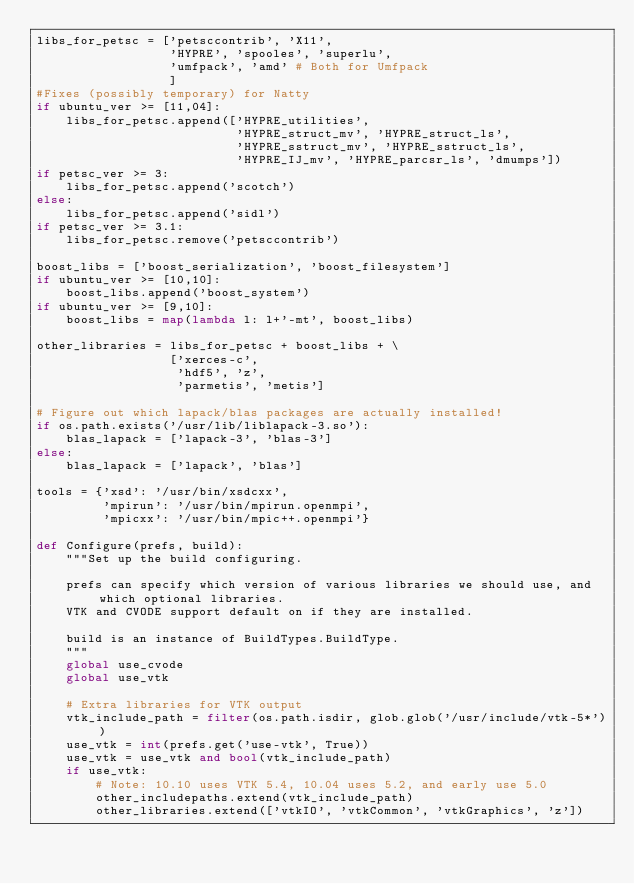Convert code to text. <code><loc_0><loc_0><loc_500><loc_500><_Python_>libs_for_petsc = ['petsccontrib', 'X11',
                  'HYPRE', 'spooles', 'superlu',
                  'umfpack', 'amd' # Both for Umfpack
                  ]
#Fixes (possibly temporary) for Natty
if ubuntu_ver >= [11,04]:
    libs_for_petsc.append(['HYPRE_utilities', 
                           'HYPRE_struct_mv', 'HYPRE_struct_ls',  
                           'HYPRE_sstruct_mv', 'HYPRE_sstruct_ls', 
                           'HYPRE_IJ_mv', 'HYPRE_parcsr_ls', 'dmumps'])
if petsc_ver >= 3:
    libs_for_petsc.append('scotch')
else:
    libs_for_petsc.append('sidl')
if petsc_ver >= 3.1:
    libs_for_petsc.remove('petsccontrib')

boost_libs = ['boost_serialization', 'boost_filesystem']
if ubuntu_ver >= [10,10]:
    boost_libs.append('boost_system')
if ubuntu_ver >= [9,10]:
    boost_libs = map(lambda l: l+'-mt', boost_libs)

other_libraries = libs_for_petsc + boost_libs + \
                  ['xerces-c',
                   'hdf5', 'z',
                   'parmetis', 'metis']

# Figure out which lapack/blas packages are actually installed!
if os.path.exists('/usr/lib/liblapack-3.so'):
    blas_lapack = ['lapack-3', 'blas-3']
else:
    blas_lapack = ['lapack', 'blas']

tools = {'xsd': '/usr/bin/xsdcxx',
         'mpirun': '/usr/bin/mpirun.openmpi',
         'mpicxx': '/usr/bin/mpic++.openmpi'}

def Configure(prefs, build):
    """Set up the build configuring.
    
    prefs can specify which version of various libraries we should use, and which optional libraries.
    VTK and CVODE support default on if they are installed.
    
    build is an instance of BuildTypes.BuildType.
    """
    global use_cvode
    global use_vtk
    
    # Extra libraries for VTK output
    vtk_include_path = filter(os.path.isdir, glob.glob('/usr/include/vtk-5*'))
    use_vtk = int(prefs.get('use-vtk', True))
    use_vtk = use_vtk and bool(vtk_include_path)
    if use_vtk:
        # Note: 10.10 uses VTK 5.4, 10.04 uses 5.2, and early use 5.0
        other_includepaths.extend(vtk_include_path)
        other_libraries.extend(['vtkIO', 'vtkCommon', 'vtkGraphics', 'z'])</code> 